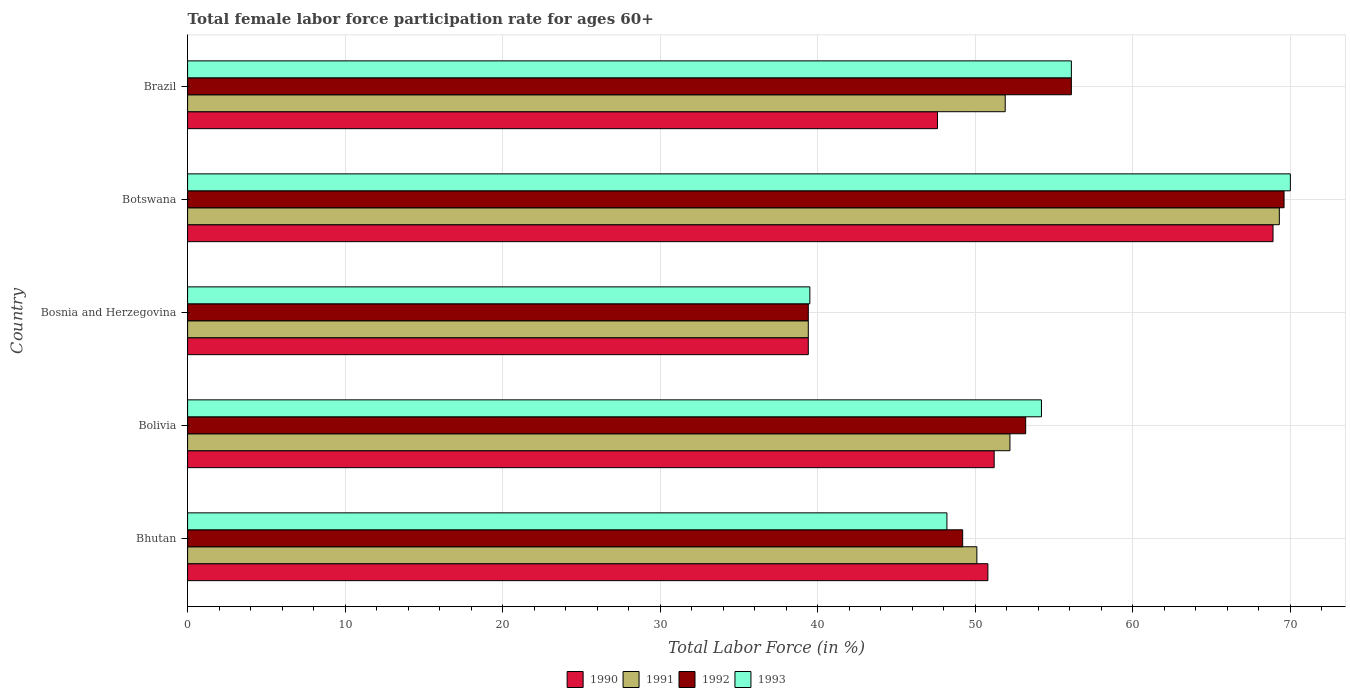How many groups of bars are there?
Give a very brief answer. 5. Are the number of bars per tick equal to the number of legend labels?
Give a very brief answer. Yes. Are the number of bars on each tick of the Y-axis equal?
Your answer should be very brief. Yes. How many bars are there on the 1st tick from the bottom?
Ensure brevity in your answer.  4. What is the label of the 2nd group of bars from the top?
Ensure brevity in your answer.  Botswana. What is the female labor force participation rate in 1993 in Bolivia?
Your answer should be compact. 54.2. Across all countries, what is the maximum female labor force participation rate in 1990?
Offer a terse response. 68.9. Across all countries, what is the minimum female labor force participation rate in 1992?
Offer a terse response. 39.4. In which country was the female labor force participation rate in 1993 maximum?
Provide a short and direct response. Botswana. In which country was the female labor force participation rate in 1993 minimum?
Your response must be concise. Bosnia and Herzegovina. What is the total female labor force participation rate in 1990 in the graph?
Offer a terse response. 257.9. What is the difference between the female labor force participation rate in 1992 in Botswana and that in Brazil?
Your response must be concise. 13.5. What is the difference between the female labor force participation rate in 1993 in Botswana and the female labor force participation rate in 1991 in Bosnia and Herzegovina?
Offer a terse response. 30.6. What is the average female labor force participation rate in 1991 per country?
Give a very brief answer. 52.58. What is the difference between the female labor force participation rate in 1993 and female labor force participation rate in 1990 in Bosnia and Herzegovina?
Your answer should be compact. 0.1. What is the ratio of the female labor force participation rate in 1991 in Botswana to that in Brazil?
Offer a terse response. 1.34. Is the difference between the female labor force participation rate in 1993 in Bolivia and Brazil greater than the difference between the female labor force participation rate in 1990 in Bolivia and Brazil?
Provide a succinct answer. No. What is the difference between the highest and the second highest female labor force participation rate in 1991?
Offer a very short reply. 17.1. What is the difference between the highest and the lowest female labor force participation rate in 1992?
Your answer should be compact. 30.2. In how many countries, is the female labor force participation rate in 1990 greater than the average female labor force participation rate in 1990 taken over all countries?
Provide a succinct answer. 1. Is the sum of the female labor force participation rate in 1992 in Bolivia and Brazil greater than the maximum female labor force participation rate in 1991 across all countries?
Keep it short and to the point. Yes. What does the 1st bar from the bottom in Bolivia represents?
Give a very brief answer. 1990. Is it the case that in every country, the sum of the female labor force participation rate in 1992 and female labor force participation rate in 1991 is greater than the female labor force participation rate in 1990?
Give a very brief answer. Yes. Are all the bars in the graph horizontal?
Provide a succinct answer. Yes. How many countries are there in the graph?
Give a very brief answer. 5. What is the difference between two consecutive major ticks on the X-axis?
Give a very brief answer. 10. Are the values on the major ticks of X-axis written in scientific E-notation?
Offer a terse response. No. Does the graph contain grids?
Provide a short and direct response. Yes. How many legend labels are there?
Provide a short and direct response. 4. How are the legend labels stacked?
Keep it short and to the point. Horizontal. What is the title of the graph?
Offer a terse response. Total female labor force participation rate for ages 60+. Does "1998" appear as one of the legend labels in the graph?
Offer a very short reply. No. What is the label or title of the Y-axis?
Ensure brevity in your answer.  Country. What is the Total Labor Force (in %) of 1990 in Bhutan?
Your answer should be compact. 50.8. What is the Total Labor Force (in %) in 1991 in Bhutan?
Make the answer very short. 50.1. What is the Total Labor Force (in %) of 1992 in Bhutan?
Your response must be concise. 49.2. What is the Total Labor Force (in %) of 1993 in Bhutan?
Offer a terse response. 48.2. What is the Total Labor Force (in %) of 1990 in Bolivia?
Keep it short and to the point. 51.2. What is the Total Labor Force (in %) of 1991 in Bolivia?
Make the answer very short. 52.2. What is the Total Labor Force (in %) of 1992 in Bolivia?
Offer a terse response. 53.2. What is the Total Labor Force (in %) in 1993 in Bolivia?
Offer a very short reply. 54.2. What is the Total Labor Force (in %) of 1990 in Bosnia and Herzegovina?
Your response must be concise. 39.4. What is the Total Labor Force (in %) in 1991 in Bosnia and Herzegovina?
Make the answer very short. 39.4. What is the Total Labor Force (in %) of 1992 in Bosnia and Herzegovina?
Ensure brevity in your answer.  39.4. What is the Total Labor Force (in %) of 1993 in Bosnia and Herzegovina?
Offer a very short reply. 39.5. What is the Total Labor Force (in %) of 1990 in Botswana?
Offer a terse response. 68.9. What is the Total Labor Force (in %) of 1991 in Botswana?
Keep it short and to the point. 69.3. What is the Total Labor Force (in %) of 1992 in Botswana?
Your response must be concise. 69.6. What is the Total Labor Force (in %) of 1993 in Botswana?
Keep it short and to the point. 70. What is the Total Labor Force (in %) in 1990 in Brazil?
Offer a terse response. 47.6. What is the Total Labor Force (in %) of 1991 in Brazil?
Ensure brevity in your answer.  51.9. What is the Total Labor Force (in %) in 1992 in Brazil?
Ensure brevity in your answer.  56.1. What is the Total Labor Force (in %) in 1993 in Brazil?
Your response must be concise. 56.1. Across all countries, what is the maximum Total Labor Force (in %) in 1990?
Ensure brevity in your answer.  68.9. Across all countries, what is the maximum Total Labor Force (in %) of 1991?
Ensure brevity in your answer.  69.3. Across all countries, what is the maximum Total Labor Force (in %) in 1992?
Keep it short and to the point. 69.6. Across all countries, what is the maximum Total Labor Force (in %) in 1993?
Ensure brevity in your answer.  70. Across all countries, what is the minimum Total Labor Force (in %) in 1990?
Keep it short and to the point. 39.4. Across all countries, what is the minimum Total Labor Force (in %) of 1991?
Offer a very short reply. 39.4. Across all countries, what is the minimum Total Labor Force (in %) of 1992?
Ensure brevity in your answer.  39.4. Across all countries, what is the minimum Total Labor Force (in %) of 1993?
Offer a very short reply. 39.5. What is the total Total Labor Force (in %) of 1990 in the graph?
Make the answer very short. 257.9. What is the total Total Labor Force (in %) of 1991 in the graph?
Your answer should be compact. 262.9. What is the total Total Labor Force (in %) of 1992 in the graph?
Give a very brief answer. 267.5. What is the total Total Labor Force (in %) in 1993 in the graph?
Provide a short and direct response. 268. What is the difference between the Total Labor Force (in %) in 1990 in Bhutan and that in Bolivia?
Make the answer very short. -0.4. What is the difference between the Total Labor Force (in %) of 1991 in Bhutan and that in Bosnia and Herzegovina?
Your answer should be very brief. 10.7. What is the difference between the Total Labor Force (in %) of 1993 in Bhutan and that in Bosnia and Herzegovina?
Your answer should be very brief. 8.7. What is the difference between the Total Labor Force (in %) in 1990 in Bhutan and that in Botswana?
Make the answer very short. -18.1. What is the difference between the Total Labor Force (in %) of 1991 in Bhutan and that in Botswana?
Your answer should be compact. -19.2. What is the difference between the Total Labor Force (in %) of 1992 in Bhutan and that in Botswana?
Give a very brief answer. -20.4. What is the difference between the Total Labor Force (in %) in 1993 in Bhutan and that in Botswana?
Offer a very short reply. -21.8. What is the difference between the Total Labor Force (in %) of 1990 in Bhutan and that in Brazil?
Offer a very short reply. 3.2. What is the difference between the Total Labor Force (in %) in 1991 in Bhutan and that in Brazil?
Your response must be concise. -1.8. What is the difference between the Total Labor Force (in %) of 1992 in Bhutan and that in Brazil?
Your answer should be very brief. -6.9. What is the difference between the Total Labor Force (in %) of 1993 in Bhutan and that in Brazil?
Provide a succinct answer. -7.9. What is the difference between the Total Labor Force (in %) of 1990 in Bolivia and that in Bosnia and Herzegovina?
Make the answer very short. 11.8. What is the difference between the Total Labor Force (in %) of 1991 in Bolivia and that in Bosnia and Herzegovina?
Your answer should be compact. 12.8. What is the difference between the Total Labor Force (in %) in 1992 in Bolivia and that in Bosnia and Herzegovina?
Offer a terse response. 13.8. What is the difference between the Total Labor Force (in %) in 1990 in Bolivia and that in Botswana?
Keep it short and to the point. -17.7. What is the difference between the Total Labor Force (in %) in 1991 in Bolivia and that in Botswana?
Your response must be concise. -17.1. What is the difference between the Total Labor Force (in %) of 1992 in Bolivia and that in Botswana?
Offer a terse response. -16.4. What is the difference between the Total Labor Force (in %) of 1993 in Bolivia and that in Botswana?
Keep it short and to the point. -15.8. What is the difference between the Total Labor Force (in %) of 1990 in Bolivia and that in Brazil?
Your response must be concise. 3.6. What is the difference between the Total Labor Force (in %) of 1990 in Bosnia and Herzegovina and that in Botswana?
Keep it short and to the point. -29.5. What is the difference between the Total Labor Force (in %) in 1991 in Bosnia and Herzegovina and that in Botswana?
Offer a very short reply. -29.9. What is the difference between the Total Labor Force (in %) of 1992 in Bosnia and Herzegovina and that in Botswana?
Your answer should be very brief. -30.2. What is the difference between the Total Labor Force (in %) in 1993 in Bosnia and Herzegovina and that in Botswana?
Provide a short and direct response. -30.5. What is the difference between the Total Labor Force (in %) in 1991 in Bosnia and Herzegovina and that in Brazil?
Provide a short and direct response. -12.5. What is the difference between the Total Labor Force (in %) in 1992 in Bosnia and Herzegovina and that in Brazil?
Give a very brief answer. -16.7. What is the difference between the Total Labor Force (in %) in 1993 in Bosnia and Herzegovina and that in Brazil?
Offer a terse response. -16.6. What is the difference between the Total Labor Force (in %) in 1990 in Botswana and that in Brazil?
Offer a very short reply. 21.3. What is the difference between the Total Labor Force (in %) in 1990 in Bhutan and the Total Labor Force (in %) in 1991 in Bolivia?
Offer a terse response. -1.4. What is the difference between the Total Labor Force (in %) of 1991 in Bhutan and the Total Labor Force (in %) of 1992 in Bolivia?
Ensure brevity in your answer.  -3.1. What is the difference between the Total Labor Force (in %) in 1991 in Bhutan and the Total Labor Force (in %) in 1993 in Bolivia?
Provide a succinct answer. -4.1. What is the difference between the Total Labor Force (in %) in 1990 in Bhutan and the Total Labor Force (in %) in 1991 in Bosnia and Herzegovina?
Offer a terse response. 11.4. What is the difference between the Total Labor Force (in %) of 1990 in Bhutan and the Total Labor Force (in %) of 1993 in Bosnia and Herzegovina?
Provide a succinct answer. 11.3. What is the difference between the Total Labor Force (in %) in 1991 in Bhutan and the Total Labor Force (in %) in 1992 in Bosnia and Herzegovina?
Provide a short and direct response. 10.7. What is the difference between the Total Labor Force (in %) of 1992 in Bhutan and the Total Labor Force (in %) of 1993 in Bosnia and Herzegovina?
Provide a succinct answer. 9.7. What is the difference between the Total Labor Force (in %) in 1990 in Bhutan and the Total Labor Force (in %) in 1991 in Botswana?
Your answer should be very brief. -18.5. What is the difference between the Total Labor Force (in %) in 1990 in Bhutan and the Total Labor Force (in %) in 1992 in Botswana?
Make the answer very short. -18.8. What is the difference between the Total Labor Force (in %) in 1990 in Bhutan and the Total Labor Force (in %) in 1993 in Botswana?
Keep it short and to the point. -19.2. What is the difference between the Total Labor Force (in %) in 1991 in Bhutan and the Total Labor Force (in %) in 1992 in Botswana?
Give a very brief answer. -19.5. What is the difference between the Total Labor Force (in %) in 1991 in Bhutan and the Total Labor Force (in %) in 1993 in Botswana?
Keep it short and to the point. -19.9. What is the difference between the Total Labor Force (in %) of 1992 in Bhutan and the Total Labor Force (in %) of 1993 in Botswana?
Your answer should be very brief. -20.8. What is the difference between the Total Labor Force (in %) in 1990 in Bhutan and the Total Labor Force (in %) in 1992 in Brazil?
Offer a terse response. -5.3. What is the difference between the Total Labor Force (in %) in 1990 in Bhutan and the Total Labor Force (in %) in 1993 in Brazil?
Keep it short and to the point. -5.3. What is the difference between the Total Labor Force (in %) of 1990 in Bolivia and the Total Labor Force (in %) of 1993 in Bosnia and Herzegovina?
Offer a terse response. 11.7. What is the difference between the Total Labor Force (in %) in 1991 in Bolivia and the Total Labor Force (in %) in 1993 in Bosnia and Herzegovina?
Provide a short and direct response. 12.7. What is the difference between the Total Labor Force (in %) in 1992 in Bolivia and the Total Labor Force (in %) in 1993 in Bosnia and Herzegovina?
Your answer should be very brief. 13.7. What is the difference between the Total Labor Force (in %) in 1990 in Bolivia and the Total Labor Force (in %) in 1991 in Botswana?
Make the answer very short. -18.1. What is the difference between the Total Labor Force (in %) in 1990 in Bolivia and the Total Labor Force (in %) in 1992 in Botswana?
Your answer should be compact. -18.4. What is the difference between the Total Labor Force (in %) in 1990 in Bolivia and the Total Labor Force (in %) in 1993 in Botswana?
Make the answer very short. -18.8. What is the difference between the Total Labor Force (in %) in 1991 in Bolivia and the Total Labor Force (in %) in 1992 in Botswana?
Make the answer very short. -17.4. What is the difference between the Total Labor Force (in %) in 1991 in Bolivia and the Total Labor Force (in %) in 1993 in Botswana?
Give a very brief answer. -17.8. What is the difference between the Total Labor Force (in %) in 1992 in Bolivia and the Total Labor Force (in %) in 1993 in Botswana?
Make the answer very short. -16.8. What is the difference between the Total Labor Force (in %) of 1990 in Bolivia and the Total Labor Force (in %) of 1993 in Brazil?
Give a very brief answer. -4.9. What is the difference between the Total Labor Force (in %) of 1990 in Bosnia and Herzegovina and the Total Labor Force (in %) of 1991 in Botswana?
Give a very brief answer. -29.9. What is the difference between the Total Labor Force (in %) in 1990 in Bosnia and Herzegovina and the Total Labor Force (in %) in 1992 in Botswana?
Make the answer very short. -30.2. What is the difference between the Total Labor Force (in %) in 1990 in Bosnia and Herzegovina and the Total Labor Force (in %) in 1993 in Botswana?
Offer a very short reply. -30.6. What is the difference between the Total Labor Force (in %) of 1991 in Bosnia and Herzegovina and the Total Labor Force (in %) of 1992 in Botswana?
Give a very brief answer. -30.2. What is the difference between the Total Labor Force (in %) in 1991 in Bosnia and Herzegovina and the Total Labor Force (in %) in 1993 in Botswana?
Provide a succinct answer. -30.6. What is the difference between the Total Labor Force (in %) in 1992 in Bosnia and Herzegovina and the Total Labor Force (in %) in 1993 in Botswana?
Offer a terse response. -30.6. What is the difference between the Total Labor Force (in %) of 1990 in Bosnia and Herzegovina and the Total Labor Force (in %) of 1991 in Brazil?
Your answer should be very brief. -12.5. What is the difference between the Total Labor Force (in %) of 1990 in Bosnia and Herzegovina and the Total Labor Force (in %) of 1992 in Brazil?
Your response must be concise. -16.7. What is the difference between the Total Labor Force (in %) in 1990 in Bosnia and Herzegovina and the Total Labor Force (in %) in 1993 in Brazil?
Provide a succinct answer. -16.7. What is the difference between the Total Labor Force (in %) of 1991 in Bosnia and Herzegovina and the Total Labor Force (in %) of 1992 in Brazil?
Ensure brevity in your answer.  -16.7. What is the difference between the Total Labor Force (in %) in 1991 in Bosnia and Herzegovina and the Total Labor Force (in %) in 1993 in Brazil?
Ensure brevity in your answer.  -16.7. What is the difference between the Total Labor Force (in %) of 1992 in Bosnia and Herzegovina and the Total Labor Force (in %) of 1993 in Brazil?
Provide a succinct answer. -16.7. What is the difference between the Total Labor Force (in %) of 1991 in Botswana and the Total Labor Force (in %) of 1992 in Brazil?
Your answer should be very brief. 13.2. What is the difference between the Total Labor Force (in %) in 1991 in Botswana and the Total Labor Force (in %) in 1993 in Brazil?
Your answer should be very brief. 13.2. What is the difference between the Total Labor Force (in %) of 1992 in Botswana and the Total Labor Force (in %) of 1993 in Brazil?
Offer a terse response. 13.5. What is the average Total Labor Force (in %) of 1990 per country?
Provide a short and direct response. 51.58. What is the average Total Labor Force (in %) in 1991 per country?
Your response must be concise. 52.58. What is the average Total Labor Force (in %) in 1992 per country?
Offer a terse response. 53.5. What is the average Total Labor Force (in %) of 1993 per country?
Your answer should be very brief. 53.6. What is the difference between the Total Labor Force (in %) of 1990 and Total Labor Force (in %) of 1991 in Bhutan?
Provide a short and direct response. 0.7. What is the difference between the Total Labor Force (in %) in 1990 and Total Labor Force (in %) in 1993 in Bhutan?
Provide a short and direct response. 2.6. What is the difference between the Total Labor Force (in %) in 1991 and Total Labor Force (in %) in 1993 in Bhutan?
Your answer should be compact. 1.9. What is the difference between the Total Labor Force (in %) of 1990 and Total Labor Force (in %) of 1992 in Bolivia?
Your response must be concise. -2. What is the difference between the Total Labor Force (in %) in 1990 and Total Labor Force (in %) in 1991 in Bosnia and Herzegovina?
Offer a very short reply. 0. What is the difference between the Total Labor Force (in %) in 1990 and Total Labor Force (in %) in 1992 in Bosnia and Herzegovina?
Give a very brief answer. 0. What is the difference between the Total Labor Force (in %) in 1991 and Total Labor Force (in %) in 1992 in Bosnia and Herzegovina?
Provide a succinct answer. 0. What is the difference between the Total Labor Force (in %) of 1992 and Total Labor Force (in %) of 1993 in Bosnia and Herzegovina?
Offer a very short reply. -0.1. What is the difference between the Total Labor Force (in %) of 1990 and Total Labor Force (in %) of 1991 in Botswana?
Keep it short and to the point. -0.4. What is the difference between the Total Labor Force (in %) in 1990 and Total Labor Force (in %) in 1992 in Botswana?
Your response must be concise. -0.7. What is the difference between the Total Labor Force (in %) in 1990 and Total Labor Force (in %) in 1993 in Botswana?
Make the answer very short. -1.1. What is the difference between the Total Labor Force (in %) of 1991 and Total Labor Force (in %) of 1993 in Botswana?
Offer a very short reply. -0.7. What is the difference between the Total Labor Force (in %) of 1990 and Total Labor Force (in %) of 1991 in Brazil?
Give a very brief answer. -4.3. What is the difference between the Total Labor Force (in %) in 1990 and Total Labor Force (in %) in 1993 in Brazil?
Make the answer very short. -8.5. What is the ratio of the Total Labor Force (in %) of 1991 in Bhutan to that in Bolivia?
Keep it short and to the point. 0.96. What is the ratio of the Total Labor Force (in %) of 1992 in Bhutan to that in Bolivia?
Offer a very short reply. 0.92. What is the ratio of the Total Labor Force (in %) in 1993 in Bhutan to that in Bolivia?
Your answer should be very brief. 0.89. What is the ratio of the Total Labor Force (in %) in 1990 in Bhutan to that in Bosnia and Herzegovina?
Provide a short and direct response. 1.29. What is the ratio of the Total Labor Force (in %) in 1991 in Bhutan to that in Bosnia and Herzegovina?
Give a very brief answer. 1.27. What is the ratio of the Total Labor Force (in %) of 1992 in Bhutan to that in Bosnia and Herzegovina?
Your answer should be very brief. 1.25. What is the ratio of the Total Labor Force (in %) of 1993 in Bhutan to that in Bosnia and Herzegovina?
Keep it short and to the point. 1.22. What is the ratio of the Total Labor Force (in %) in 1990 in Bhutan to that in Botswana?
Your response must be concise. 0.74. What is the ratio of the Total Labor Force (in %) of 1991 in Bhutan to that in Botswana?
Ensure brevity in your answer.  0.72. What is the ratio of the Total Labor Force (in %) in 1992 in Bhutan to that in Botswana?
Keep it short and to the point. 0.71. What is the ratio of the Total Labor Force (in %) in 1993 in Bhutan to that in Botswana?
Your answer should be compact. 0.69. What is the ratio of the Total Labor Force (in %) in 1990 in Bhutan to that in Brazil?
Keep it short and to the point. 1.07. What is the ratio of the Total Labor Force (in %) of 1991 in Bhutan to that in Brazil?
Offer a terse response. 0.97. What is the ratio of the Total Labor Force (in %) in 1992 in Bhutan to that in Brazil?
Offer a very short reply. 0.88. What is the ratio of the Total Labor Force (in %) in 1993 in Bhutan to that in Brazil?
Offer a very short reply. 0.86. What is the ratio of the Total Labor Force (in %) in 1990 in Bolivia to that in Bosnia and Herzegovina?
Ensure brevity in your answer.  1.3. What is the ratio of the Total Labor Force (in %) of 1991 in Bolivia to that in Bosnia and Herzegovina?
Keep it short and to the point. 1.32. What is the ratio of the Total Labor Force (in %) of 1992 in Bolivia to that in Bosnia and Herzegovina?
Offer a very short reply. 1.35. What is the ratio of the Total Labor Force (in %) in 1993 in Bolivia to that in Bosnia and Herzegovina?
Provide a succinct answer. 1.37. What is the ratio of the Total Labor Force (in %) of 1990 in Bolivia to that in Botswana?
Offer a terse response. 0.74. What is the ratio of the Total Labor Force (in %) of 1991 in Bolivia to that in Botswana?
Keep it short and to the point. 0.75. What is the ratio of the Total Labor Force (in %) in 1992 in Bolivia to that in Botswana?
Offer a terse response. 0.76. What is the ratio of the Total Labor Force (in %) of 1993 in Bolivia to that in Botswana?
Keep it short and to the point. 0.77. What is the ratio of the Total Labor Force (in %) of 1990 in Bolivia to that in Brazil?
Your answer should be very brief. 1.08. What is the ratio of the Total Labor Force (in %) of 1992 in Bolivia to that in Brazil?
Provide a short and direct response. 0.95. What is the ratio of the Total Labor Force (in %) in 1993 in Bolivia to that in Brazil?
Provide a short and direct response. 0.97. What is the ratio of the Total Labor Force (in %) in 1990 in Bosnia and Herzegovina to that in Botswana?
Provide a succinct answer. 0.57. What is the ratio of the Total Labor Force (in %) in 1991 in Bosnia and Herzegovina to that in Botswana?
Ensure brevity in your answer.  0.57. What is the ratio of the Total Labor Force (in %) of 1992 in Bosnia and Herzegovina to that in Botswana?
Keep it short and to the point. 0.57. What is the ratio of the Total Labor Force (in %) in 1993 in Bosnia and Herzegovina to that in Botswana?
Keep it short and to the point. 0.56. What is the ratio of the Total Labor Force (in %) in 1990 in Bosnia and Herzegovina to that in Brazil?
Your response must be concise. 0.83. What is the ratio of the Total Labor Force (in %) in 1991 in Bosnia and Herzegovina to that in Brazil?
Offer a very short reply. 0.76. What is the ratio of the Total Labor Force (in %) in 1992 in Bosnia and Herzegovina to that in Brazil?
Keep it short and to the point. 0.7. What is the ratio of the Total Labor Force (in %) of 1993 in Bosnia and Herzegovina to that in Brazil?
Offer a very short reply. 0.7. What is the ratio of the Total Labor Force (in %) of 1990 in Botswana to that in Brazil?
Provide a succinct answer. 1.45. What is the ratio of the Total Labor Force (in %) of 1991 in Botswana to that in Brazil?
Offer a terse response. 1.34. What is the ratio of the Total Labor Force (in %) of 1992 in Botswana to that in Brazil?
Make the answer very short. 1.24. What is the ratio of the Total Labor Force (in %) in 1993 in Botswana to that in Brazil?
Make the answer very short. 1.25. What is the difference between the highest and the second highest Total Labor Force (in %) of 1992?
Your response must be concise. 13.5. What is the difference between the highest and the lowest Total Labor Force (in %) in 1990?
Your answer should be compact. 29.5. What is the difference between the highest and the lowest Total Labor Force (in %) of 1991?
Give a very brief answer. 29.9. What is the difference between the highest and the lowest Total Labor Force (in %) in 1992?
Provide a succinct answer. 30.2. What is the difference between the highest and the lowest Total Labor Force (in %) in 1993?
Offer a very short reply. 30.5. 